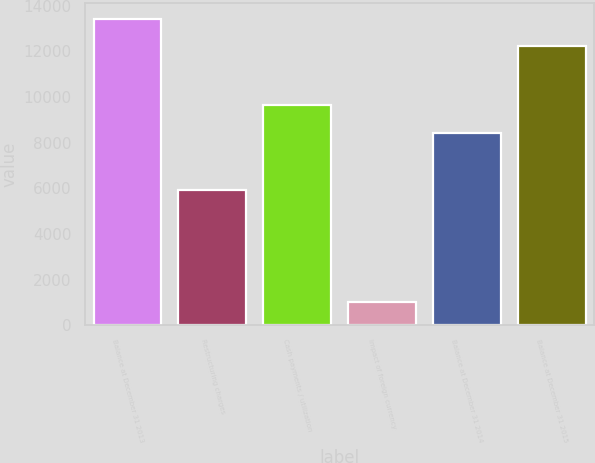Convert chart. <chart><loc_0><loc_0><loc_500><loc_500><bar_chart><fcel>Balance at December 31 2013<fcel>Restructuring charges<fcel>Cash payments / utilization<fcel>Impact of foreign currency<fcel>Balance at December 31 2014<fcel>Balance at December 31 2015<nl><fcel>13428.8<fcel>5915<fcel>9657<fcel>1007<fcel>8436<fcel>12211<nl></chart> 